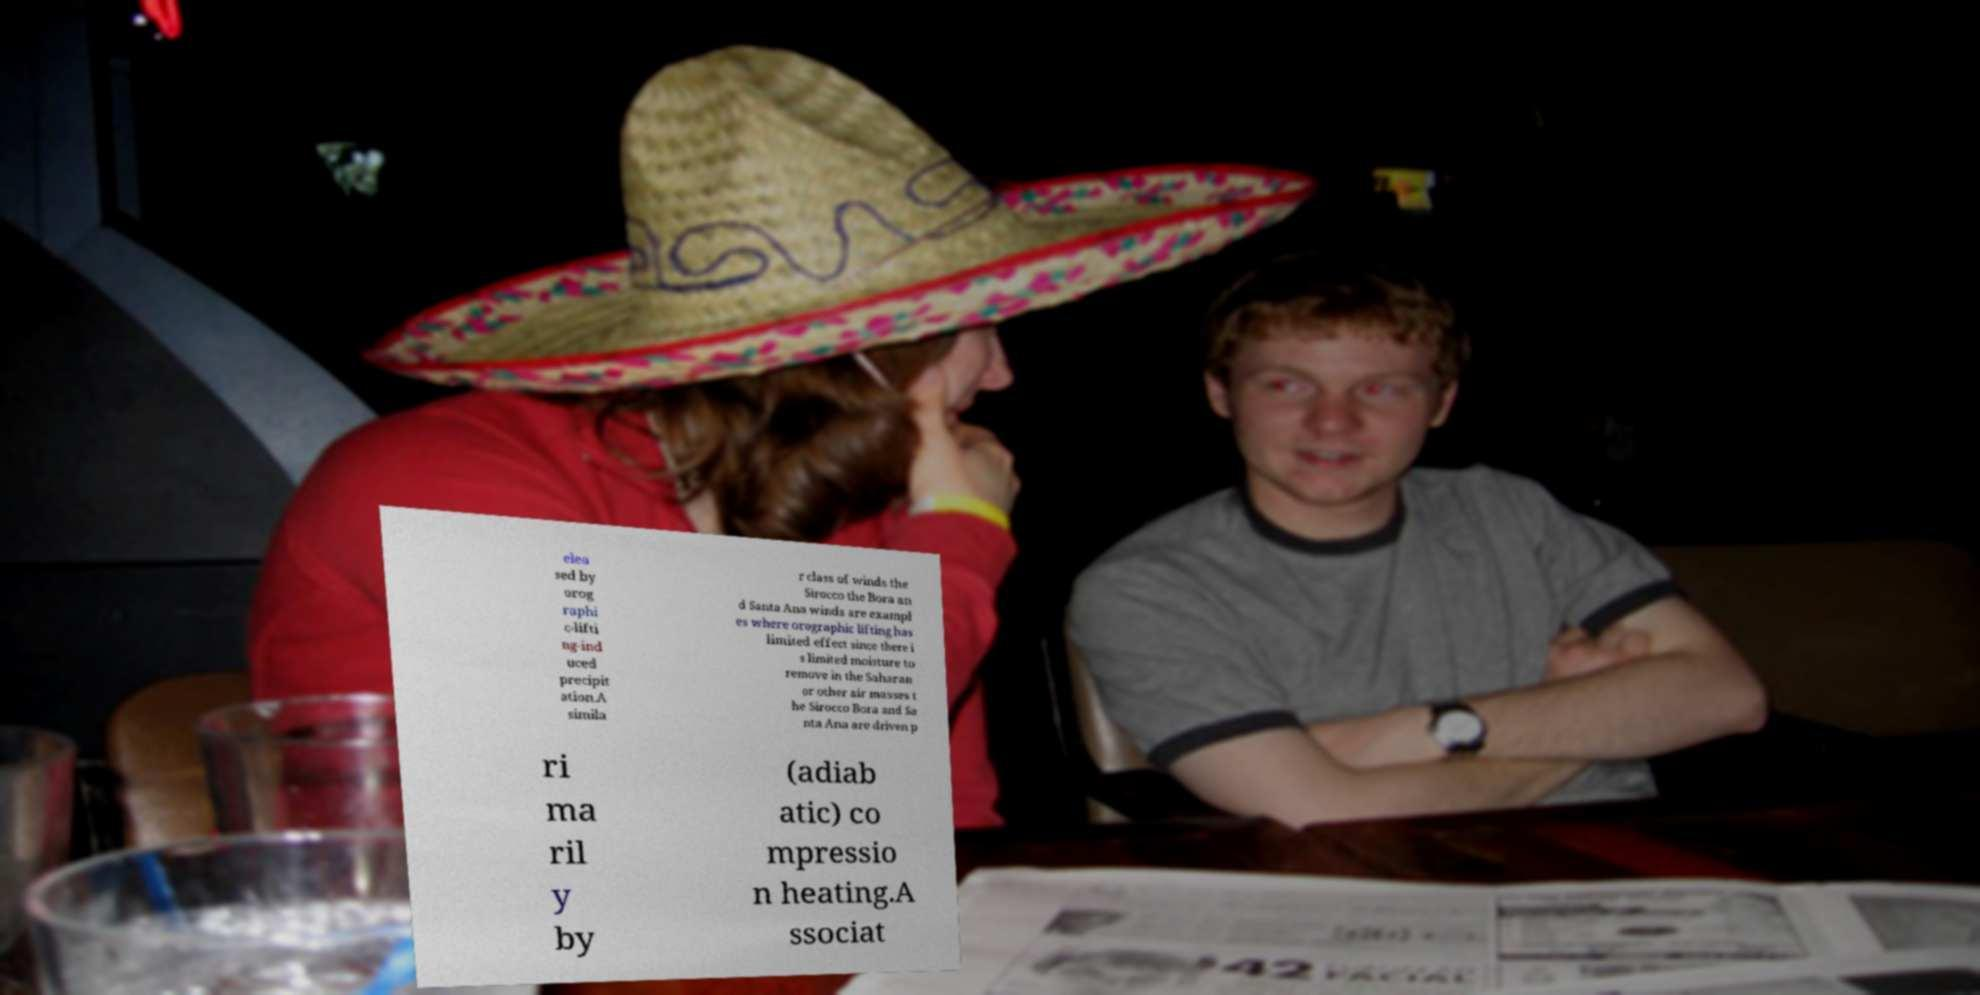Can you read and provide the text displayed in the image?This photo seems to have some interesting text. Can you extract and type it out for me? elea sed by orog raphi c-lifti ng-ind uced precipit ation.A simila r class of winds the Sirocco the Bora an d Santa Ana winds are exampl es where orographic lifting has limited effect since there i s limited moisture to remove in the Saharan or other air masses t he Sirocco Bora and Sa nta Ana are driven p ri ma ril y by (adiab atic) co mpressio n heating.A ssociat 